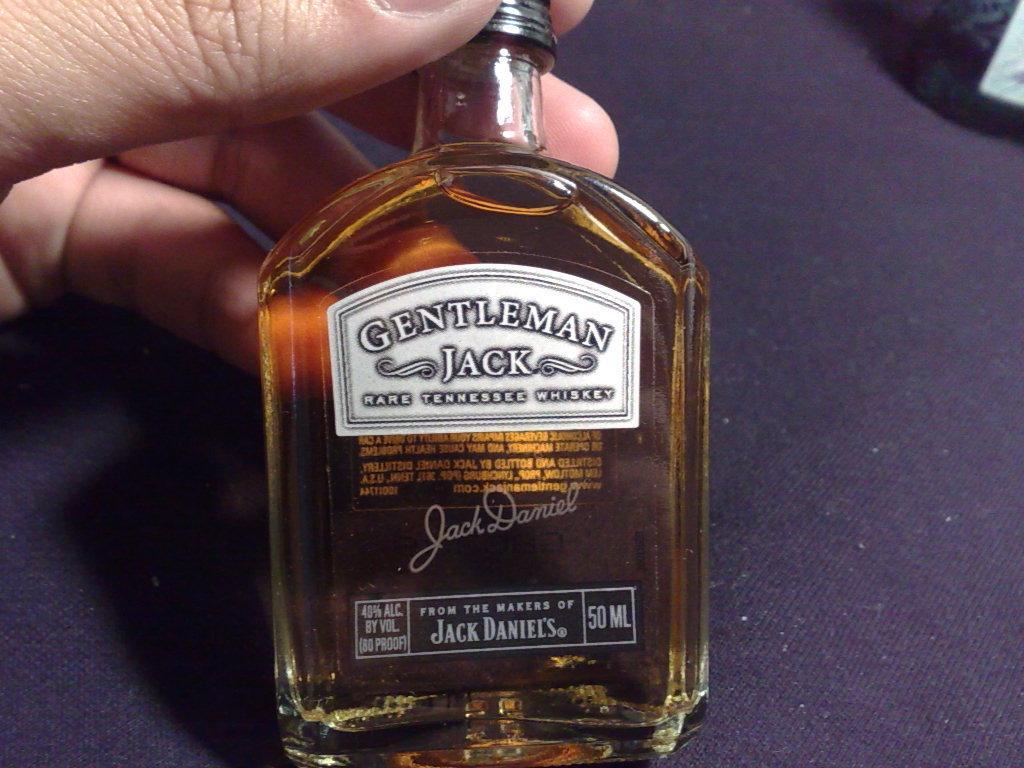Could you give a brief overview of what you see in this image? this picture shows a person holding jack Daniels bottle with his hand on the table 